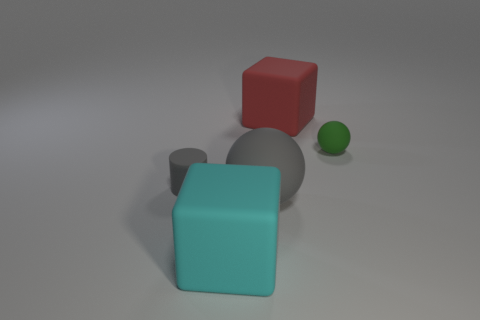Add 2 matte things. How many objects exist? 7 Subtract all spheres. How many objects are left? 3 Subtract all yellow cylinders. Subtract all gray balls. How many objects are left? 4 Add 5 small green spheres. How many small green spheres are left? 6 Add 1 tiny things. How many tiny things exist? 3 Subtract 1 gray balls. How many objects are left? 4 